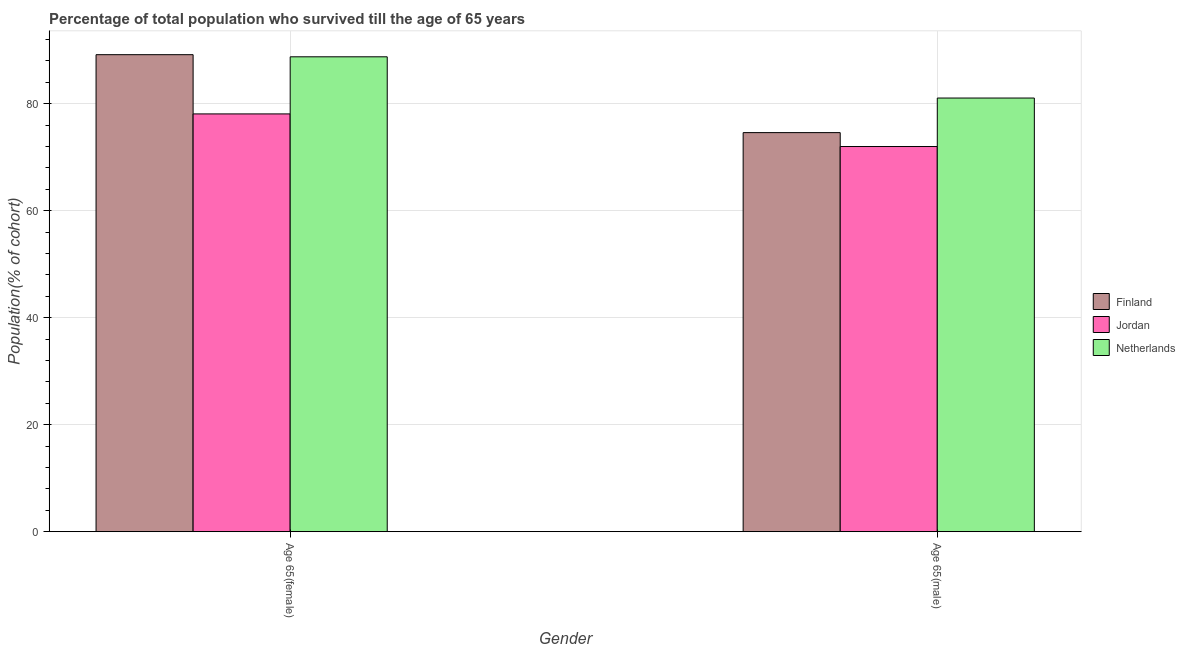How many groups of bars are there?
Provide a short and direct response. 2. What is the label of the 1st group of bars from the left?
Provide a succinct answer. Age 65(female). What is the percentage of male population who survived till age of 65 in Finland?
Your response must be concise. 74.61. Across all countries, what is the maximum percentage of male population who survived till age of 65?
Your answer should be very brief. 81.07. Across all countries, what is the minimum percentage of female population who survived till age of 65?
Your response must be concise. 78.1. In which country was the percentage of female population who survived till age of 65 maximum?
Offer a very short reply. Finland. In which country was the percentage of female population who survived till age of 65 minimum?
Your response must be concise. Jordan. What is the total percentage of female population who survived till age of 65 in the graph?
Give a very brief answer. 256.06. What is the difference between the percentage of male population who survived till age of 65 in Finland and that in Netherlands?
Your answer should be very brief. -6.46. What is the difference between the percentage of female population who survived till age of 65 in Finland and the percentage of male population who survived till age of 65 in Netherlands?
Give a very brief answer. 8.11. What is the average percentage of female population who survived till age of 65 per country?
Your answer should be compact. 85.35. What is the difference between the percentage of male population who survived till age of 65 and percentage of female population who survived till age of 65 in Finland?
Provide a short and direct response. -14.57. What is the ratio of the percentage of male population who survived till age of 65 in Finland to that in Netherlands?
Give a very brief answer. 0.92. What does the 1st bar from the right in Age 65(female) represents?
Provide a succinct answer. Netherlands. Are all the bars in the graph horizontal?
Ensure brevity in your answer.  No. How many countries are there in the graph?
Ensure brevity in your answer.  3. Does the graph contain grids?
Ensure brevity in your answer.  Yes. Where does the legend appear in the graph?
Make the answer very short. Center right. How many legend labels are there?
Offer a very short reply. 3. How are the legend labels stacked?
Your answer should be compact. Vertical. What is the title of the graph?
Offer a terse response. Percentage of total population who survived till the age of 65 years. Does "Algeria" appear as one of the legend labels in the graph?
Your response must be concise. No. What is the label or title of the X-axis?
Offer a terse response. Gender. What is the label or title of the Y-axis?
Make the answer very short. Population(% of cohort). What is the Population(% of cohort) in Finland in Age 65(female)?
Offer a terse response. 89.18. What is the Population(% of cohort) in Jordan in Age 65(female)?
Offer a terse response. 78.1. What is the Population(% of cohort) in Netherlands in Age 65(female)?
Make the answer very short. 88.78. What is the Population(% of cohort) in Finland in Age 65(male)?
Provide a short and direct response. 74.61. What is the Population(% of cohort) in Jordan in Age 65(male)?
Your answer should be very brief. 72.01. What is the Population(% of cohort) of Netherlands in Age 65(male)?
Provide a short and direct response. 81.07. Across all Gender, what is the maximum Population(% of cohort) of Finland?
Your response must be concise. 89.18. Across all Gender, what is the maximum Population(% of cohort) in Jordan?
Make the answer very short. 78.1. Across all Gender, what is the maximum Population(% of cohort) in Netherlands?
Provide a short and direct response. 88.78. Across all Gender, what is the minimum Population(% of cohort) in Finland?
Your response must be concise. 74.61. Across all Gender, what is the minimum Population(% of cohort) of Jordan?
Provide a succinct answer. 72.01. Across all Gender, what is the minimum Population(% of cohort) of Netherlands?
Give a very brief answer. 81.07. What is the total Population(% of cohort) in Finland in the graph?
Offer a terse response. 163.78. What is the total Population(% of cohort) of Jordan in the graph?
Give a very brief answer. 150.11. What is the total Population(% of cohort) of Netherlands in the graph?
Make the answer very short. 169.85. What is the difference between the Population(% of cohort) of Finland in Age 65(female) and that in Age 65(male)?
Your answer should be compact. 14.57. What is the difference between the Population(% of cohort) in Jordan in Age 65(female) and that in Age 65(male)?
Your answer should be very brief. 6.1. What is the difference between the Population(% of cohort) in Netherlands in Age 65(female) and that in Age 65(male)?
Keep it short and to the point. 7.71. What is the difference between the Population(% of cohort) in Finland in Age 65(female) and the Population(% of cohort) in Jordan in Age 65(male)?
Your response must be concise. 17.17. What is the difference between the Population(% of cohort) of Finland in Age 65(female) and the Population(% of cohort) of Netherlands in Age 65(male)?
Your answer should be very brief. 8.11. What is the difference between the Population(% of cohort) of Jordan in Age 65(female) and the Population(% of cohort) of Netherlands in Age 65(male)?
Make the answer very short. -2.97. What is the average Population(% of cohort) in Finland per Gender?
Provide a short and direct response. 81.89. What is the average Population(% of cohort) in Jordan per Gender?
Keep it short and to the point. 75.05. What is the average Population(% of cohort) of Netherlands per Gender?
Your answer should be very brief. 84.92. What is the difference between the Population(% of cohort) of Finland and Population(% of cohort) of Jordan in Age 65(female)?
Offer a very short reply. 11.07. What is the difference between the Population(% of cohort) in Finland and Population(% of cohort) in Netherlands in Age 65(female)?
Give a very brief answer. 0.4. What is the difference between the Population(% of cohort) of Jordan and Population(% of cohort) of Netherlands in Age 65(female)?
Your answer should be very brief. -10.67. What is the difference between the Population(% of cohort) of Finland and Population(% of cohort) of Jordan in Age 65(male)?
Ensure brevity in your answer.  2.6. What is the difference between the Population(% of cohort) of Finland and Population(% of cohort) of Netherlands in Age 65(male)?
Your answer should be compact. -6.46. What is the difference between the Population(% of cohort) in Jordan and Population(% of cohort) in Netherlands in Age 65(male)?
Make the answer very short. -9.06. What is the ratio of the Population(% of cohort) of Finland in Age 65(female) to that in Age 65(male)?
Your response must be concise. 1.2. What is the ratio of the Population(% of cohort) in Jordan in Age 65(female) to that in Age 65(male)?
Offer a terse response. 1.08. What is the ratio of the Population(% of cohort) of Netherlands in Age 65(female) to that in Age 65(male)?
Offer a terse response. 1.1. What is the difference between the highest and the second highest Population(% of cohort) of Finland?
Ensure brevity in your answer.  14.57. What is the difference between the highest and the second highest Population(% of cohort) of Jordan?
Provide a short and direct response. 6.1. What is the difference between the highest and the second highest Population(% of cohort) in Netherlands?
Make the answer very short. 7.71. What is the difference between the highest and the lowest Population(% of cohort) of Finland?
Ensure brevity in your answer.  14.57. What is the difference between the highest and the lowest Population(% of cohort) in Jordan?
Offer a very short reply. 6.1. What is the difference between the highest and the lowest Population(% of cohort) of Netherlands?
Offer a terse response. 7.71. 